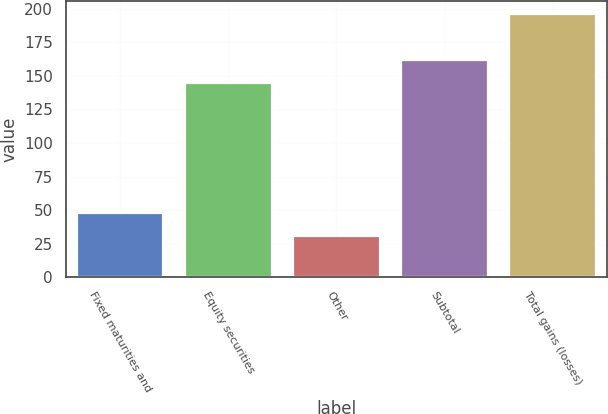<chart> <loc_0><loc_0><loc_500><loc_500><bar_chart><fcel>Fixed maturities and<fcel>Equity securities<fcel>Other<fcel>Subtotal<fcel>Total gains (losses)<nl><fcel>47.5<fcel>145<fcel>31<fcel>161.5<fcel>196<nl></chart> 